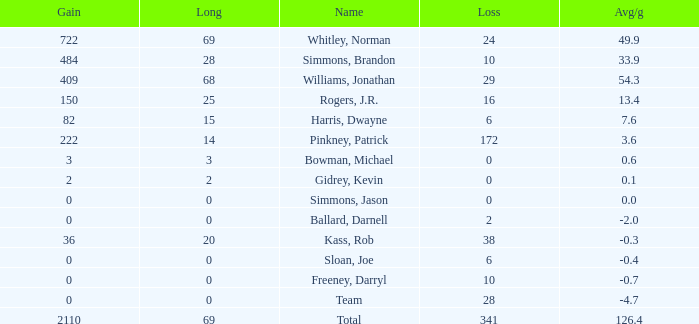Parse the full table. {'header': ['Gain', 'Long', 'Name', 'Loss', 'Avg/g'], 'rows': [['722', '69', 'Whitley, Norman', '24', '49.9'], ['484', '28', 'Simmons, Brandon', '10', '33.9'], ['409', '68', 'Williams, Jonathan', '29', '54.3'], ['150', '25', 'Rogers, J.R.', '16', '13.4'], ['82', '15', 'Harris, Dwayne', '6', '7.6'], ['222', '14', 'Pinkney, Patrick', '172', '3.6'], ['3', '3', 'Bowman, Michael', '0', '0.6'], ['2', '2', 'Gidrey, Kevin', '0', '0.1'], ['0', '0', 'Simmons, Jason', '0', '0.0'], ['0', '0', 'Ballard, Darnell', '2', '-2.0'], ['36', '20', 'Kass, Rob', '38', '-0.3'], ['0', '0', 'Sloan, Joe', '6', '-0.4'], ['0', '0', 'Freeney, Darryl', '10', '-0.7'], ['0', '0', 'Team', '28', '-4.7'], ['2110', '69', 'Total', '341', '126.4']]} What is the highest Loss, when Long is greater than 0, when Gain is greater than 484, and when Avg/g is greater than 126.4? None. 